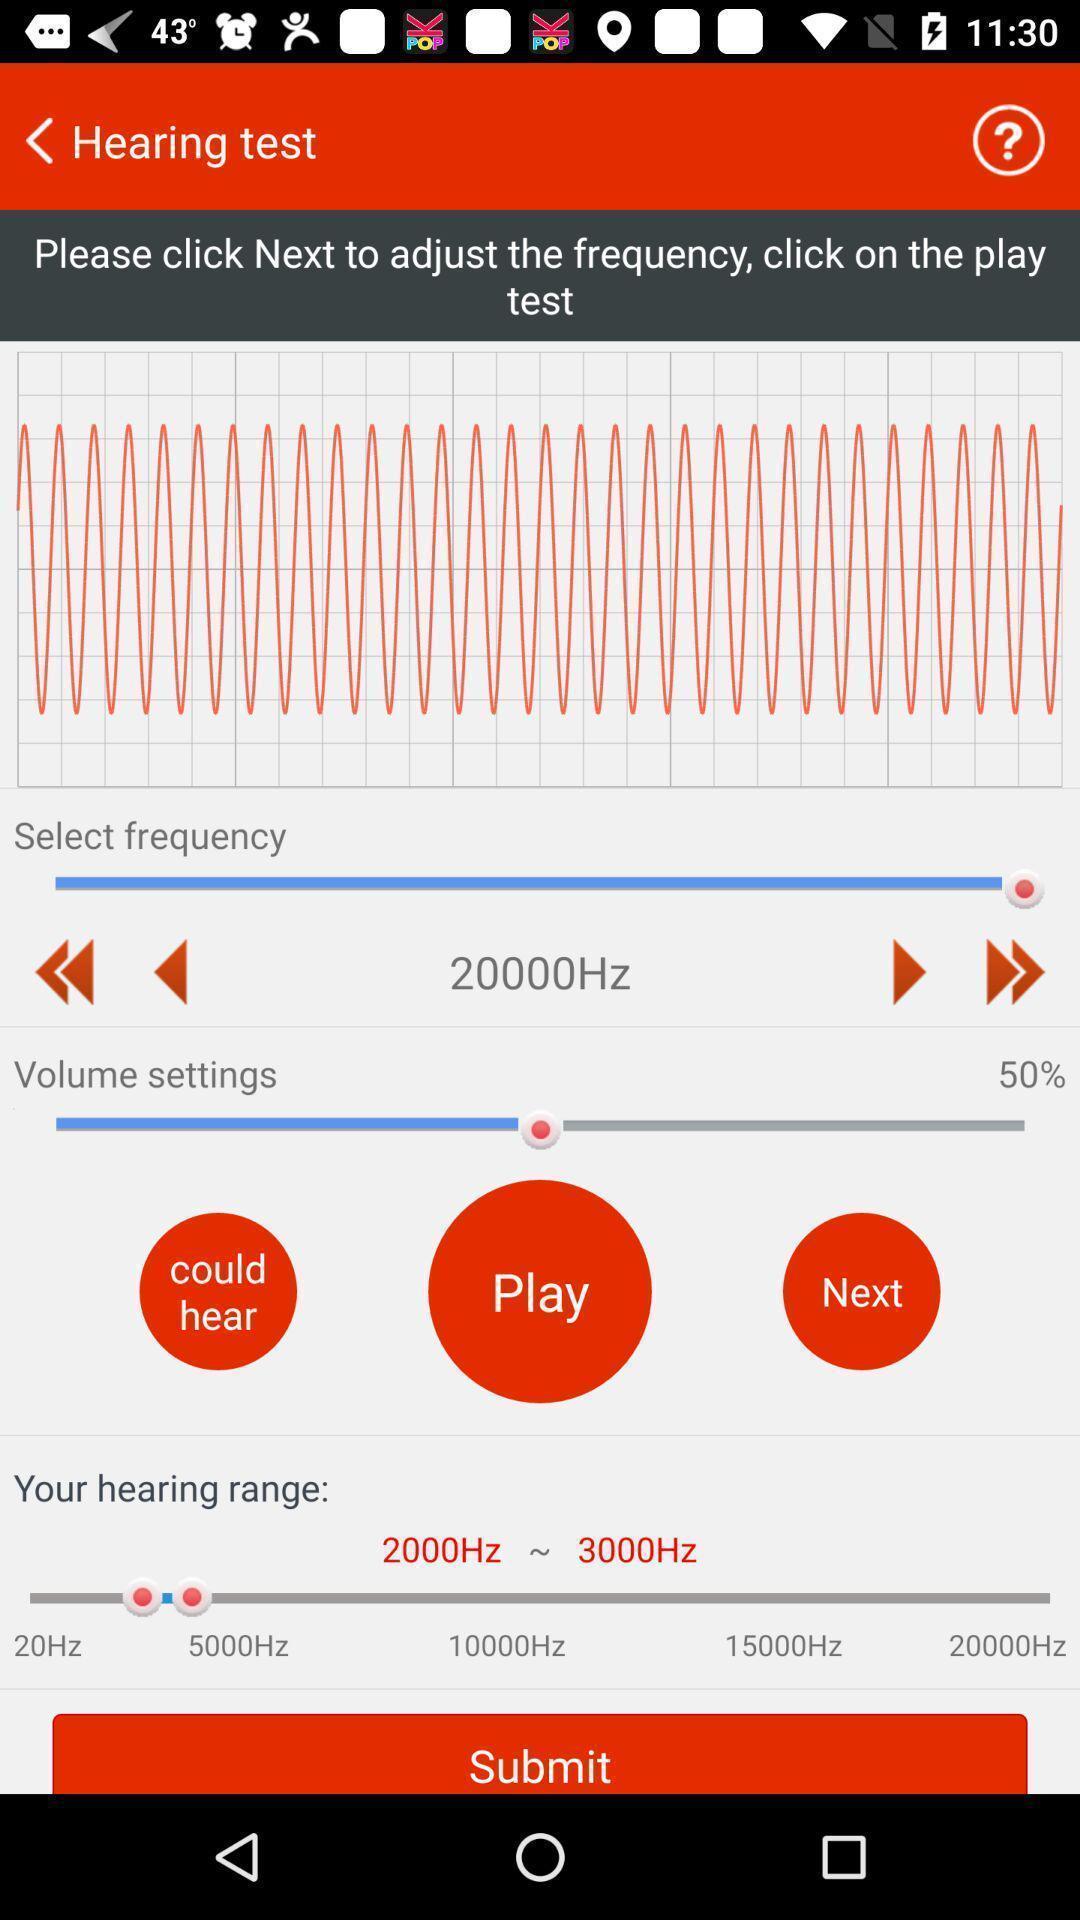What can you discern from this picture? Page showing hearing test in app. 